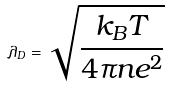<formula> <loc_0><loc_0><loc_500><loc_500>\lambda _ { D } = \sqrt { \frac { k _ { B } T } { 4 \pi n e ^ { 2 } } }</formula> 